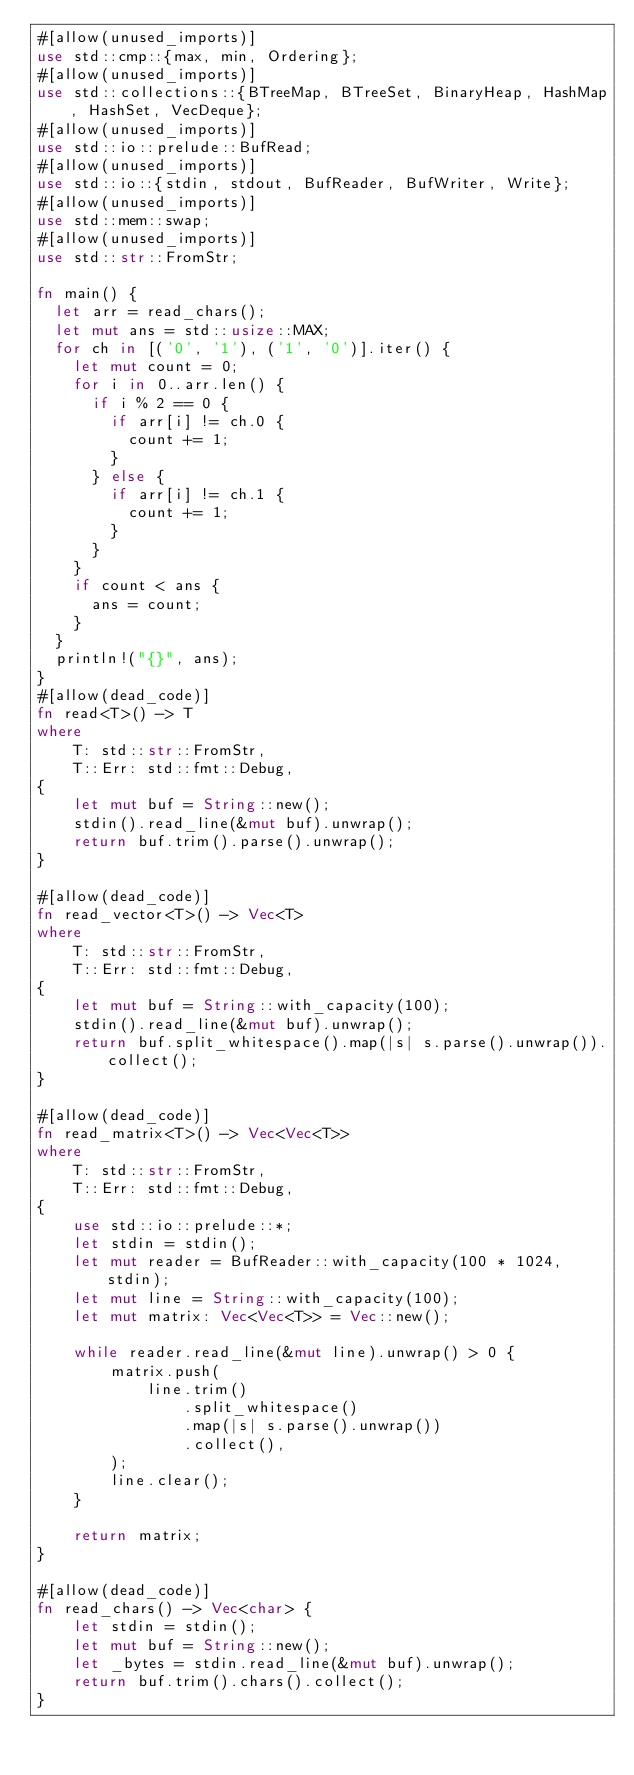<code> <loc_0><loc_0><loc_500><loc_500><_Rust_>#[allow(unused_imports)]
use std::cmp::{max, min, Ordering};
#[allow(unused_imports)]
use std::collections::{BTreeMap, BTreeSet, BinaryHeap, HashMap, HashSet, VecDeque};
#[allow(unused_imports)]
use std::io::prelude::BufRead;
#[allow(unused_imports)]
use std::io::{stdin, stdout, BufReader, BufWriter, Write};
#[allow(unused_imports)]
use std::mem::swap;
#[allow(unused_imports)]
use std::str::FromStr;

fn main() {
	let arr = read_chars();
	let mut ans = std::usize::MAX;
	for ch in [('0', '1'), ('1', '0')].iter() {
		let mut count = 0;
		for i in 0..arr.len() {
			if i % 2 == 0 {
				if arr[i] != ch.0 {
					count += 1;
				}
			} else {
				if arr[i] != ch.1 {
					count += 1;
				}
			}
		}
		if count < ans {
			ans = count;
		}
	}
	println!("{}", ans);
}
#[allow(dead_code)]
fn read<T>() -> T
where
    T: std::str::FromStr,
    T::Err: std::fmt::Debug,
{
    let mut buf = String::new();
    stdin().read_line(&mut buf).unwrap();
    return buf.trim().parse().unwrap();
}

#[allow(dead_code)]
fn read_vector<T>() -> Vec<T>
where
    T: std::str::FromStr,
    T::Err: std::fmt::Debug,
{
    let mut buf = String::with_capacity(100);
    stdin().read_line(&mut buf).unwrap();
    return buf.split_whitespace().map(|s| s.parse().unwrap()).collect();
}

#[allow(dead_code)]
fn read_matrix<T>() -> Vec<Vec<T>>
where
    T: std::str::FromStr,
    T::Err: std::fmt::Debug,
{
    use std::io::prelude::*;
    let stdin = stdin();
    let mut reader = BufReader::with_capacity(100 * 1024, stdin);
    let mut line = String::with_capacity(100);
    let mut matrix: Vec<Vec<T>> = Vec::new();

    while reader.read_line(&mut line).unwrap() > 0 {
        matrix.push(
            line.trim()
                .split_whitespace()
                .map(|s| s.parse().unwrap())
                .collect(),
        );
        line.clear();
    }

    return matrix;
}

#[allow(dead_code)]
fn read_chars() -> Vec<char> {
    let stdin = stdin();
    let mut buf = String::new();
    let _bytes = stdin.read_line(&mut buf).unwrap();
    return buf.trim().chars().collect();
}
</code> 